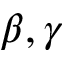Convert formula to latex. <formula><loc_0><loc_0><loc_500><loc_500>\beta , \gamma</formula> 